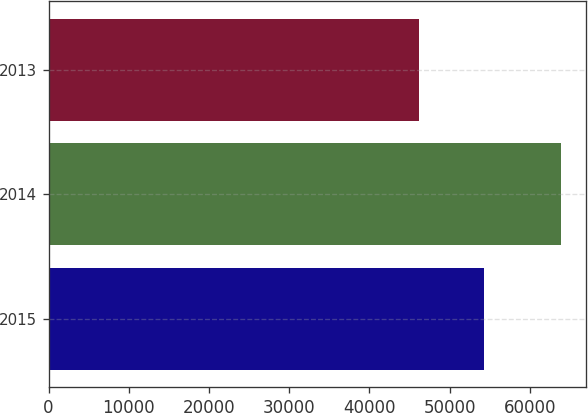Convert chart to OTSL. <chart><loc_0><loc_0><loc_500><loc_500><bar_chart><fcel>2015<fcel>2014<fcel>2013<nl><fcel>54219<fcel>63842<fcel>46208<nl></chart> 